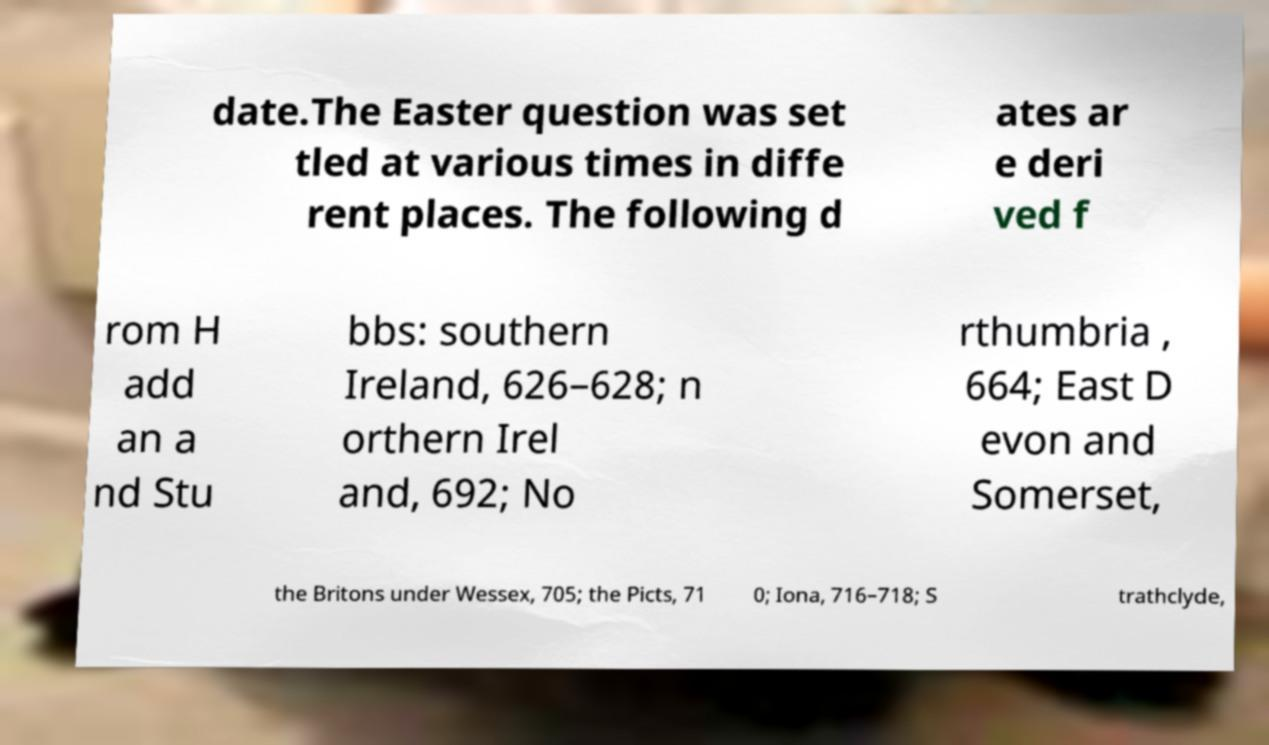I need the written content from this picture converted into text. Can you do that? date.The Easter question was set tled at various times in diffe rent places. The following d ates ar e deri ved f rom H add an a nd Stu bbs: southern Ireland, 626–628; n orthern Irel and, 692; No rthumbria , 664; East D evon and Somerset, the Britons under Wessex, 705; the Picts, 71 0; Iona, 716–718; S trathclyde, 